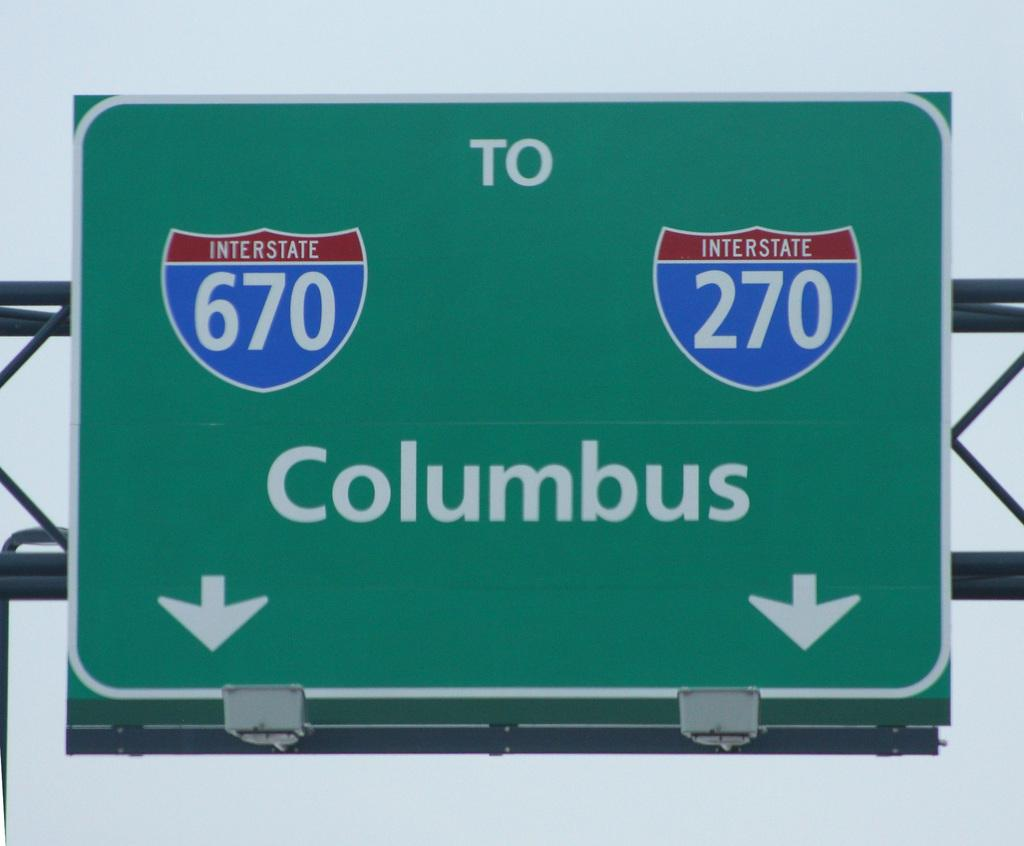<image>
Share a concise interpretation of the image provided. a sign is showing which lane for Columbus 670 or 270 